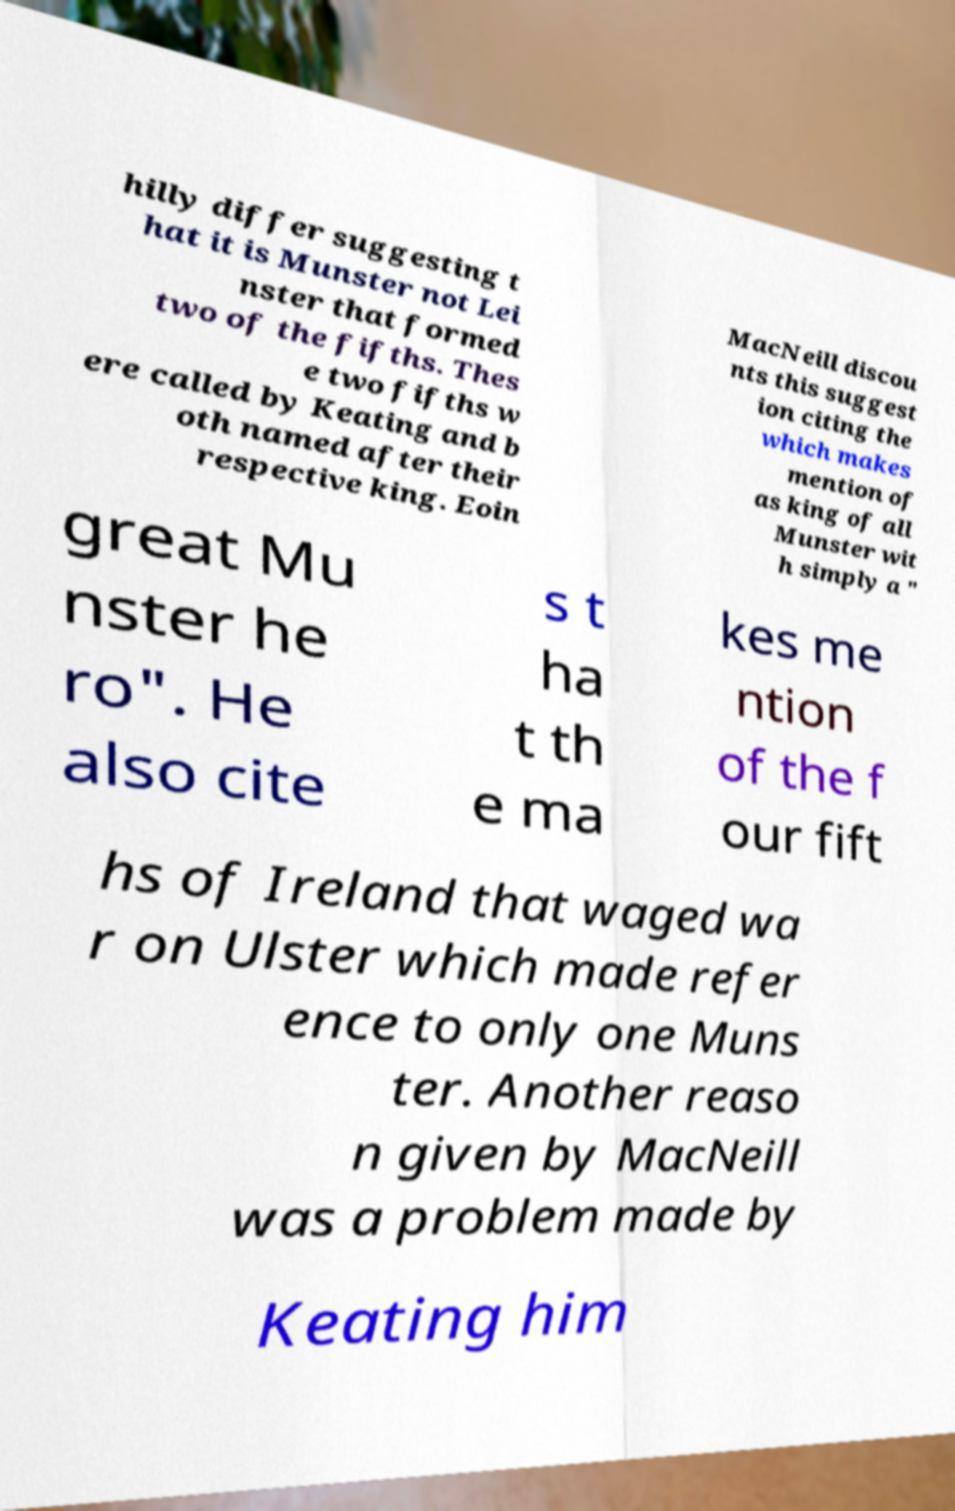Please read and relay the text visible in this image. What does it say? hilly differ suggesting t hat it is Munster not Lei nster that formed two of the fifths. Thes e two fifths w ere called by Keating and b oth named after their respective king. Eoin MacNeill discou nts this suggest ion citing the which makes mention of as king of all Munster wit h simply a " great Mu nster he ro". He also cite s t ha t th e ma kes me ntion of the f our fift hs of Ireland that waged wa r on Ulster which made refer ence to only one Muns ter. Another reaso n given by MacNeill was a problem made by Keating him 